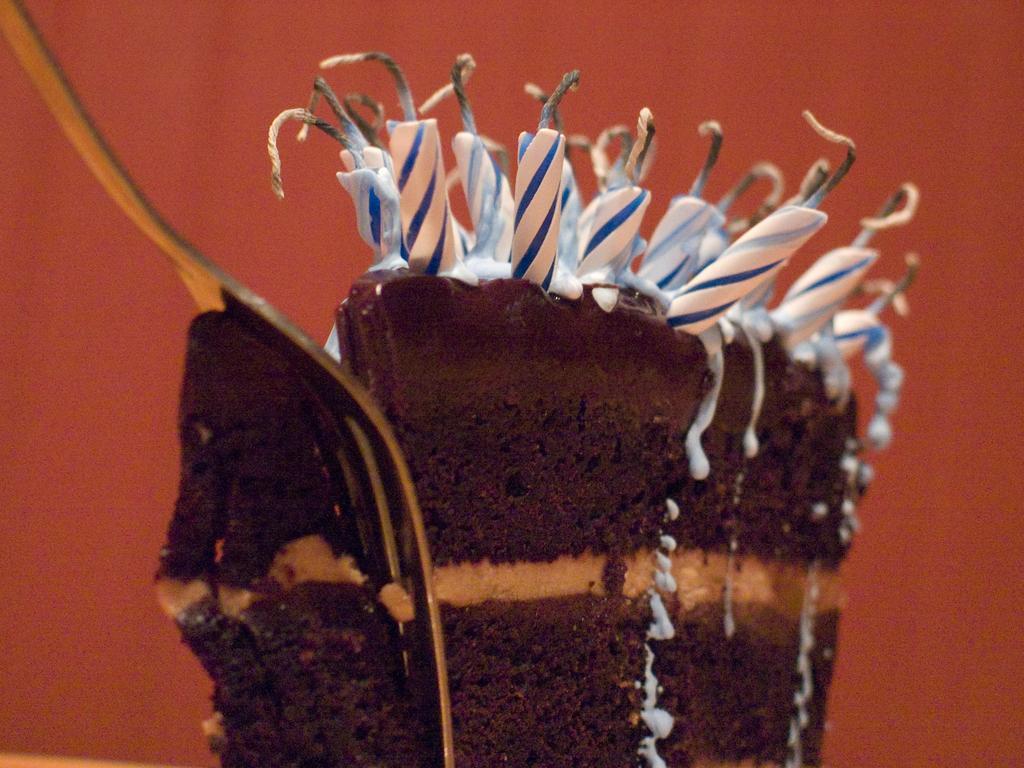Describe this image in one or two sentences. In this image, we can see a pastry. On top of that, we can see few candles and wax. Background we can see bronze color. On the left side of the image, we can see a fork. 